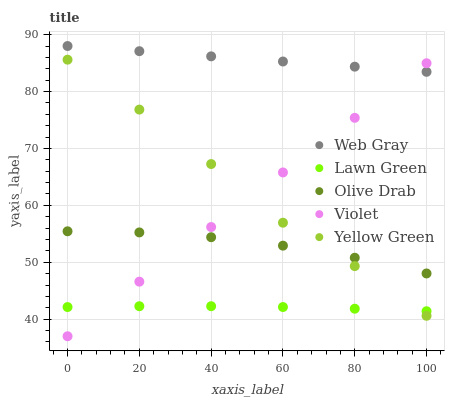Does Lawn Green have the minimum area under the curve?
Answer yes or no. Yes. Does Web Gray have the maximum area under the curve?
Answer yes or no. Yes. Does Yellow Green have the minimum area under the curve?
Answer yes or no. No. Does Yellow Green have the maximum area under the curve?
Answer yes or no. No. Is Web Gray the smoothest?
Answer yes or no. Yes. Is Yellow Green the roughest?
Answer yes or no. Yes. Is Yellow Green the smoothest?
Answer yes or no. No. Is Web Gray the roughest?
Answer yes or no. No. Does Violet have the lowest value?
Answer yes or no. Yes. Does Yellow Green have the lowest value?
Answer yes or no. No. Does Web Gray have the highest value?
Answer yes or no. Yes. Does Yellow Green have the highest value?
Answer yes or no. No. Is Lawn Green less than Olive Drab?
Answer yes or no. Yes. Is Web Gray greater than Yellow Green?
Answer yes or no. Yes. Does Violet intersect Web Gray?
Answer yes or no. Yes. Is Violet less than Web Gray?
Answer yes or no. No. Is Violet greater than Web Gray?
Answer yes or no. No. Does Lawn Green intersect Olive Drab?
Answer yes or no. No. 